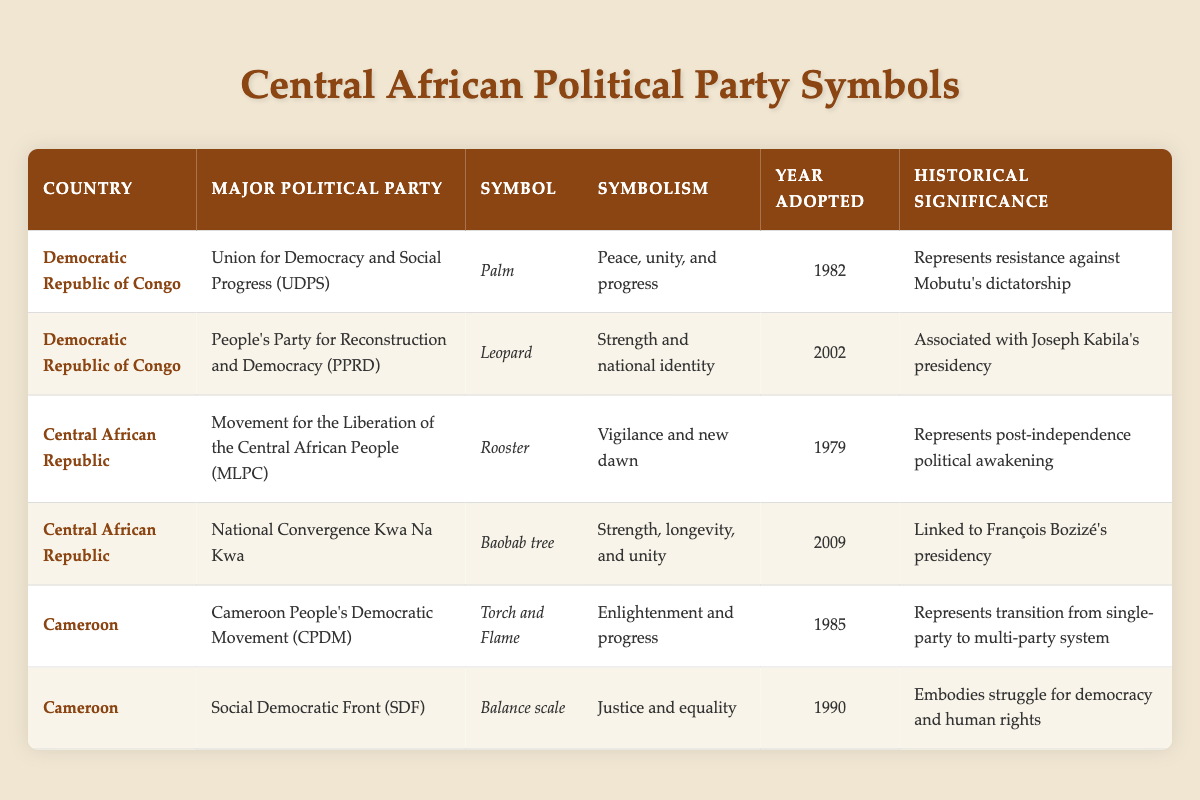What is the symbol of the Union for Democracy and Social Progress in the Democratic Republic of Congo? The table indicates that the symbol of the Union for Democracy and Social Progress (UDPS) is a palm.
Answer: Palm Which political party in Cameroon adopted its symbol in 1990? According to the table, the Social Democratic Front (SDF) adopted its symbol in 1990.
Answer: Social Democratic Front (SDF) What is the historical significance of the rooster symbol for the MLPC in the Central African Republic? The rooster symbol for the Movement for the Liberation of the Central African People (MLPC) represents post-independence political awakening, as stated in the historical significance column.
Answer: Represents post-independence political awakening Which symbol represents strength and national identity in the Democratic Republic of Congo? The leopard symbol of the People's Party for Reconstruction and Democracy (PPRD) represents strength and national identity according to the symbolism column.
Answer: Leopard Are there any political parties in the table that have a symbol related to enlightenment? Yes, the Cameroon People's Democratic Movement (CPDM) has the torch and flame symbol, which signifies enlightenment and progress.
Answer: Yes Which country has a political party that adopted a symbol in 2009, and what is that symbol? The Central African Republic has the National Convergence Kwa Na Kwa party, which adopted the baobab tree as its symbol in 2009 according to the year adopted column.
Answer: Baobab tree What are the two political parties from the Democratic Republic of Congo and their adoption years? The Union for Democracy and Social Progress (UDPS) adopted its symbol in 1982 and the People's Party for Reconstruction and Democracy (PPRD) adopted its symbol in 2002.
Answer: UDPS (1982), PPRD (2002) What is the significance of the balance scale symbol used by the Social Democratic Front? The balance scale symbolizes justice and equality, which embodies the struggle for democracy and human rights according to the significance column.
Answer: Justice and equality What is the average year adopted for the symbols of the political parties listed in Cameroon? The years adopted for the CPDM and SDF are 1985 and 1990 respectively. Average is (1985 + 1990) / 2 = 1987.5.
Answer: 1987.5 